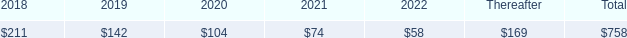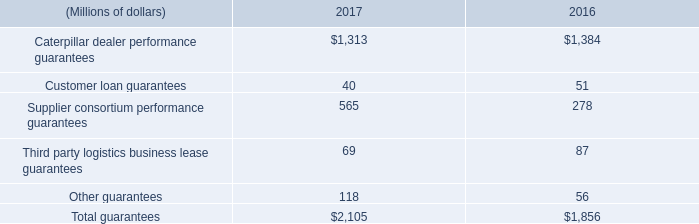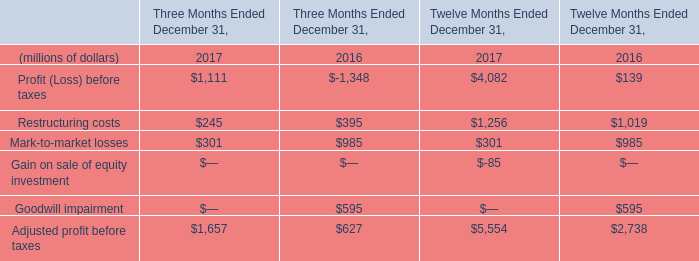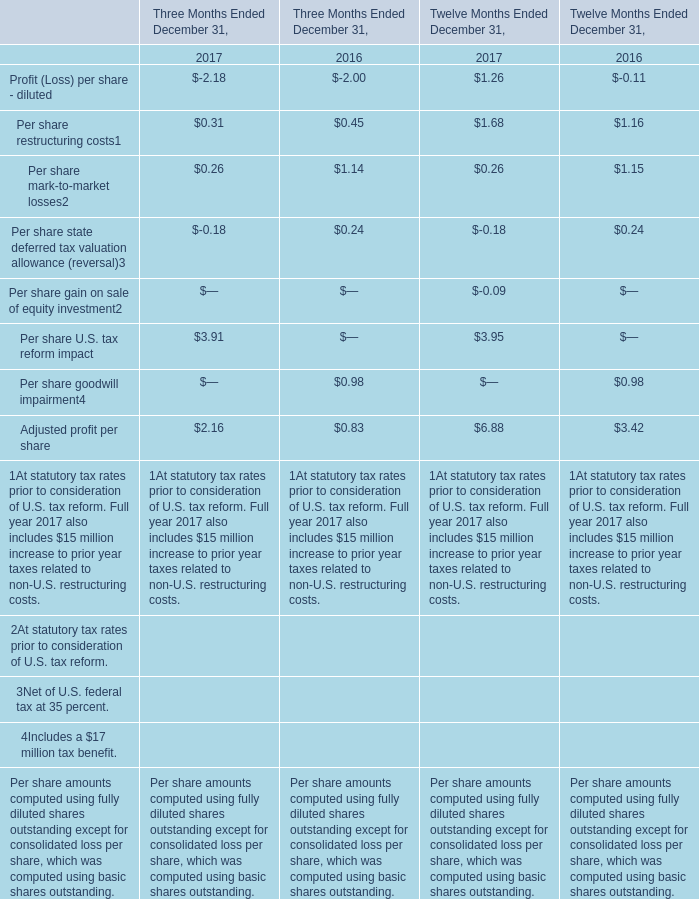What is the average amount of Caterpillar dealer performance guarantees of 2016, and Restructuring costs of Twelve Months Ended December 31, 2016 ? 
Computations: ((1384.0 + 1019.0) / 2)
Answer: 1201.5. 